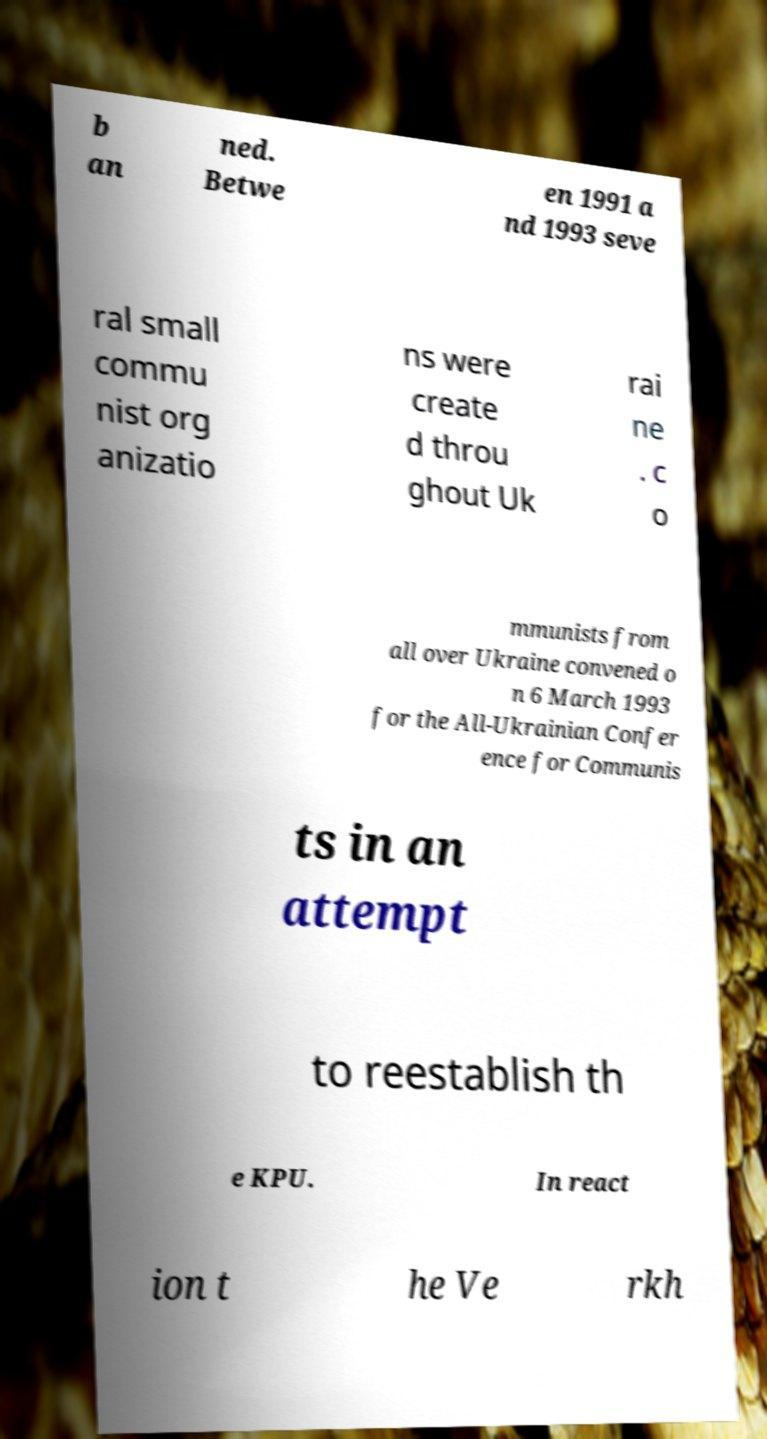Can you accurately transcribe the text from the provided image for me? b an ned. Betwe en 1991 a nd 1993 seve ral small commu nist org anizatio ns were create d throu ghout Uk rai ne . c o mmunists from all over Ukraine convened o n 6 March 1993 for the All-Ukrainian Confer ence for Communis ts in an attempt to reestablish th e KPU. In react ion t he Ve rkh 